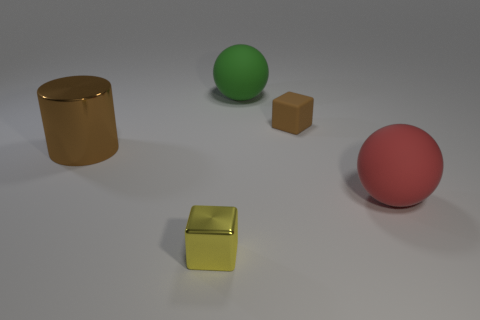Add 3 blue objects. How many objects exist? 8 Subtract all cubes. How many objects are left? 3 Add 2 large purple metal cylinders. How many large purple metal cylinders exist? 2 Subtract 1 red spheres. How many objects are left? 4 Subtract all tiny brown rubber cubes. Subtract all tiny cubes. How many objects are left? 2 Add 2 tiny blocks. How many tiny blocks are left? 4 